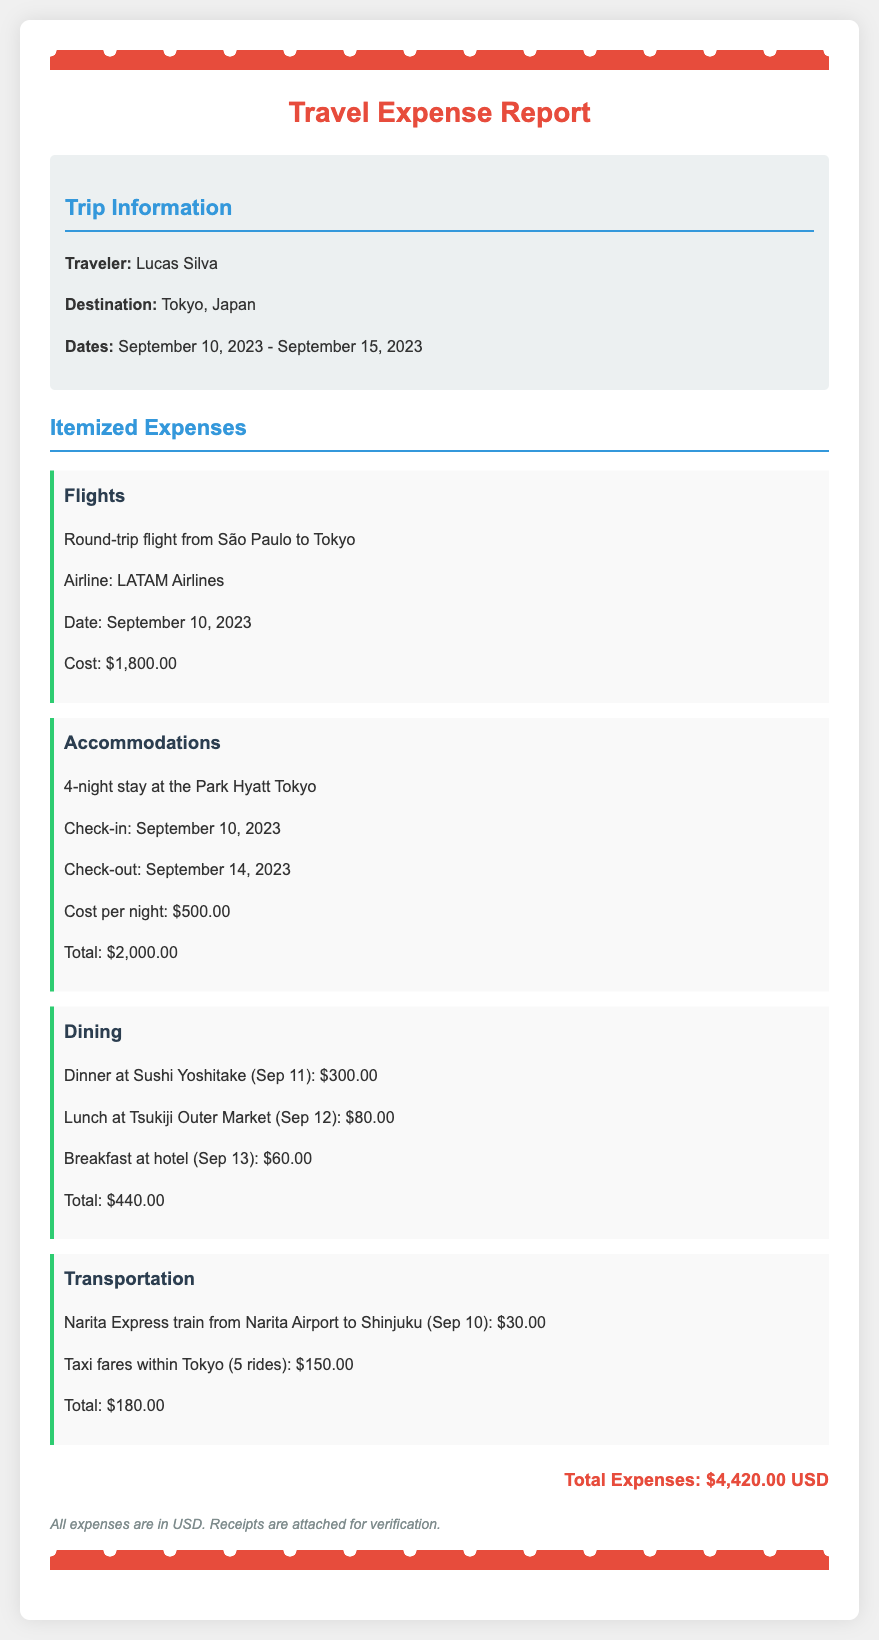What is the name of the traveler? The document specifies the traveler's name as Lucas Silva.
Answer: Lucas Silva What city did the traveler visit? The destination of the trip is stated as Tokyo, Japan.
Answer: Tokyo, Japan What was the total cost of accommodations? The total cost for accommodations can be found by multiplying the cost per night by the number of nights (4 nights at $500).
Answer: $2,000.00 How many nights did the traveler stay? The document states that the traveler stayed for 4 nights in total.
Answer: 4 nights What is the cost of the round-trip flight? The document lists the round-trip flight cost from São Paulo to Tokyo as $1,800.00.
Answer: $1,800.00 How much was spent on dining? The total dining expenses can be found by summing all dining costs mentioned (dinner, lunch, breakfast).
Answer: $440.00 What is the total expenses amount? The total expenses are calculated by adding all itemized expenses presented in the document.
Answer: $4,420.00 USD On what date did the flight depart? The document indicates the flight departed on September 10, 2023.
Answer: September 10, 2023 How many taxi rides were taken in Tokyo? The document notes that there were 5 taxi rides taken within Tokyo.
Answer: 5 rides 